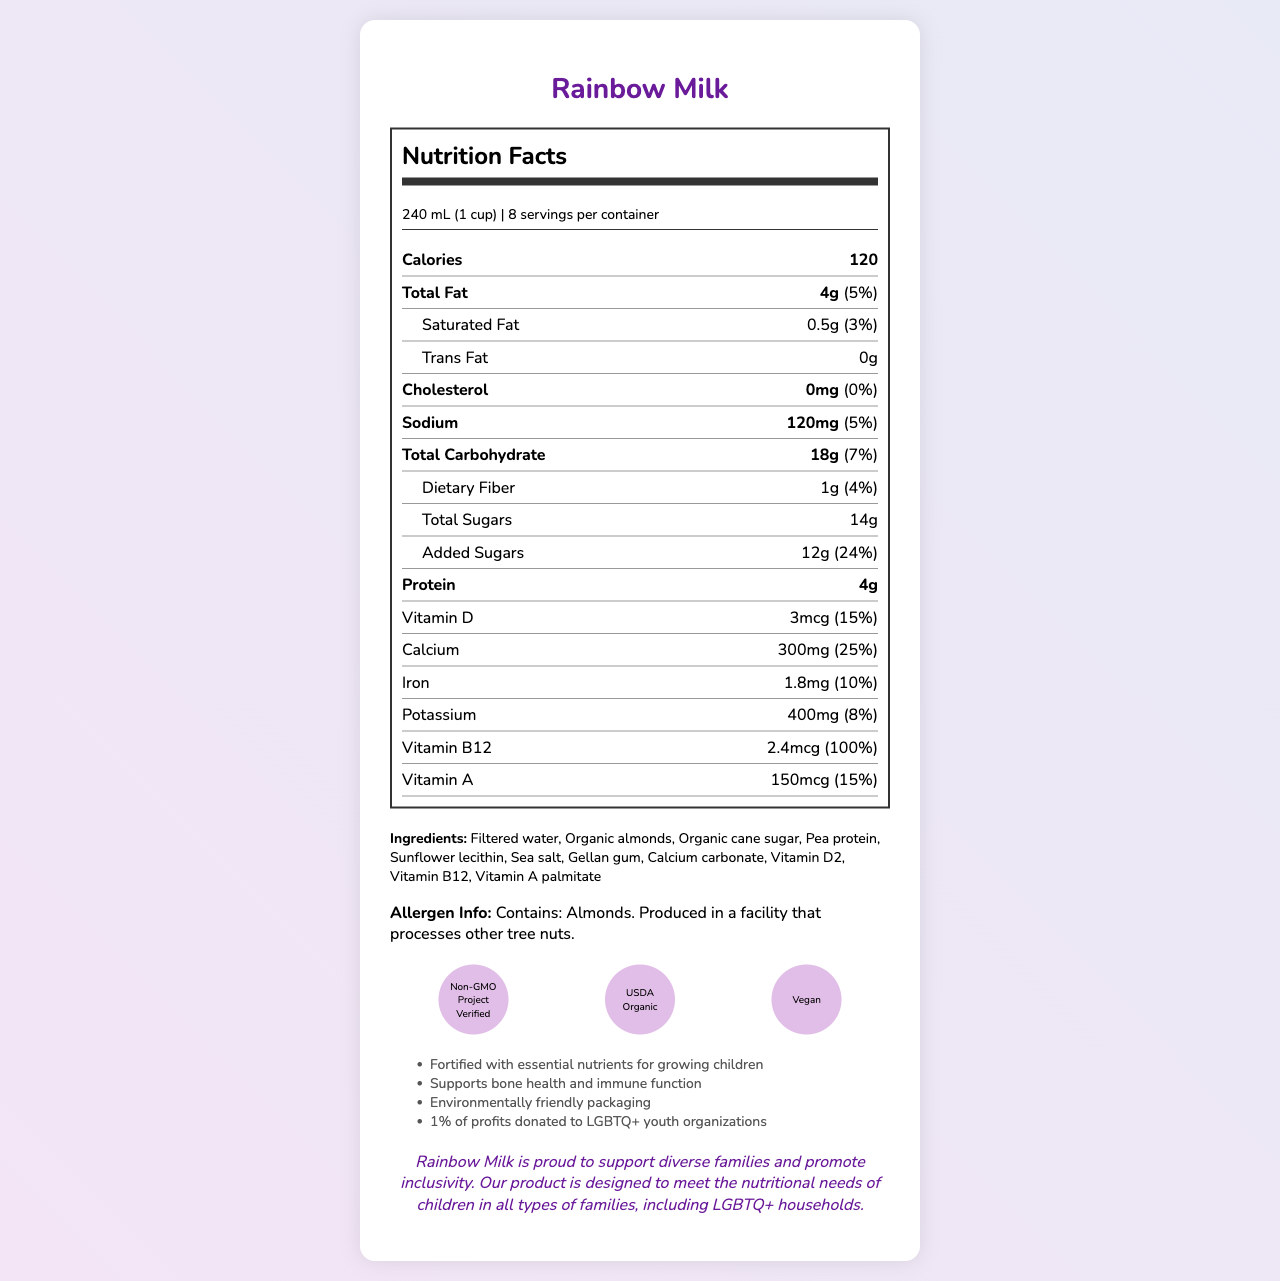What is the serving size of Rainbow Milk? The serving size is listed in the section that provides nutritional information. It is noted as 240 mL (1 cup).
Answer: 240 mL (1 cup) How many servings are there per container? The number of servings per container is displayed right above the nutritional information with the label "8 servings per container."
Answer: 8 How many calories are in one serving of Rainbow Milk? The calorie content is listed in the main nutrition facts, showing 120 calories per serving.
Answer: 120 calories What is the amount of added sugars per serving? The added sugars amount is noted under the total sugars amount, marked as 12g.
Answer: 12g What vitamins are present in Rainbow Milk? The vitamins present are listed under the nutrition facts with their respective amounts and daily percentages.
Answer: Vitamin D, Vitamin B12, Vitamin A What certifications does Rainbow Milk have? The certifications are shown in a separate section of the document with icons representing each certification.
Answer: Non-GMO Project Verified, USDA Organic, Vegan What type of allergen is present in Rainbow Milk? The allergen information specifies that the product contains almonds.
Answer: Almonds What percentage of the daily value of calcium does Rainbow Milk provide per serving? The daily value percentage for calcium is listed under its amount, showing 25%.
Answer: 25% How much protein does one serving of Rainbow Milk contain? A. 2g B. 4g C. 6g D. 8g The nutrition facts state that one serving contains 4g of protein.
Answer: B Which nutrient has the highest daily value percentage in Rainbow Milk? A. Calcium B. Vitamin B12 C. Vitamin D D. Iron Vitamin B12 has the highest daily value percentage at 100%.
Answer: B Does Rainbow Milk contain any cholesterol? The cholesterol amount is specified as 0mg with 0% of the daily value.
Answer: No Summarize the main idea of the Nutrition Facts Label for Rainbow Milk. The document provides an overview of the nutritional content, ingredient list, allergen information, certifications, and additional information about the fortified milk alternative targeting diverse families.
Answer: Rainbow Milk is a fortified, environmentally-friendly milk alternative designed for diverse families, including LGBTQ+ households. It provides essential nutrients for children, supports bone health and immune function, and includes vitamins and minerals like Calcium, Vitamin D, Vitamin B12, and Vitamin A. The product is certified Non-GMO, USDA Organic, and Vegan, and it donates 1% of profits to LGBTQ+ youth organizations. It contains almonds as an allergen. What is the main source of protein in Rainbow Milk? The document lists "pea protein" as an ingredient but does not explicitly state it as the main source of protein. Therefore, it's not clear if it's the primary source.
Answer: Not enough information 